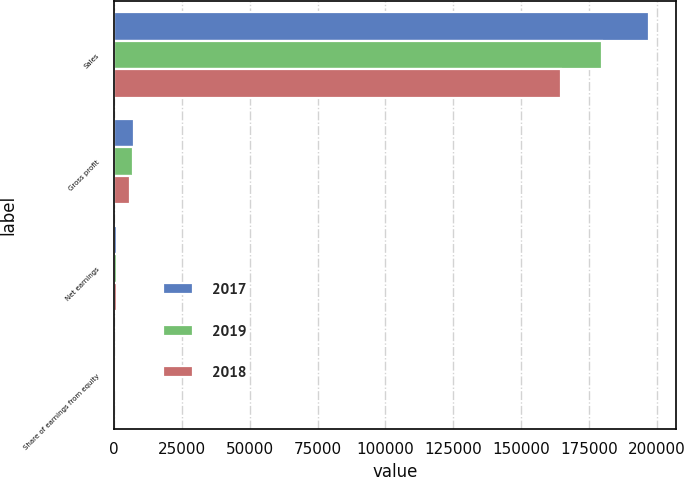Convert chart to OTSL. <chart><loc_0><loc_0><loc_500><loc_500><stacked_bar_chart><ecel><fcel>Sales<fcel>Gross profit<fcel>Net earnings<fcel>Share of earnings from equity<nl><fcel>2017<fcel>197237<fcel>7516<fcel>1037<fcel>187<nl><fcel>2019<fcel>179887<fcel>6875<fcel>1315<fcel>245<nl><fcel>2018<fcel>164844<fcel>5958<fcel>1040<fcel>143<nl></chart> 